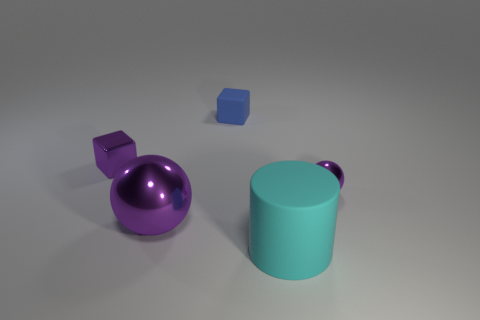Add 1 green matte balls. How many objects exist? 6 Subtract all blocks. How many objects are left? 3 Subtract all spheres. Subtract all blue things. How many objects are left? 2 Add 4 small blue things. How many small blue things are left? 5 Add 4 purple metallic things. How many purple metallic things exist? 7 Subtract 0 yellow cylinders. How many objects are left? 5 